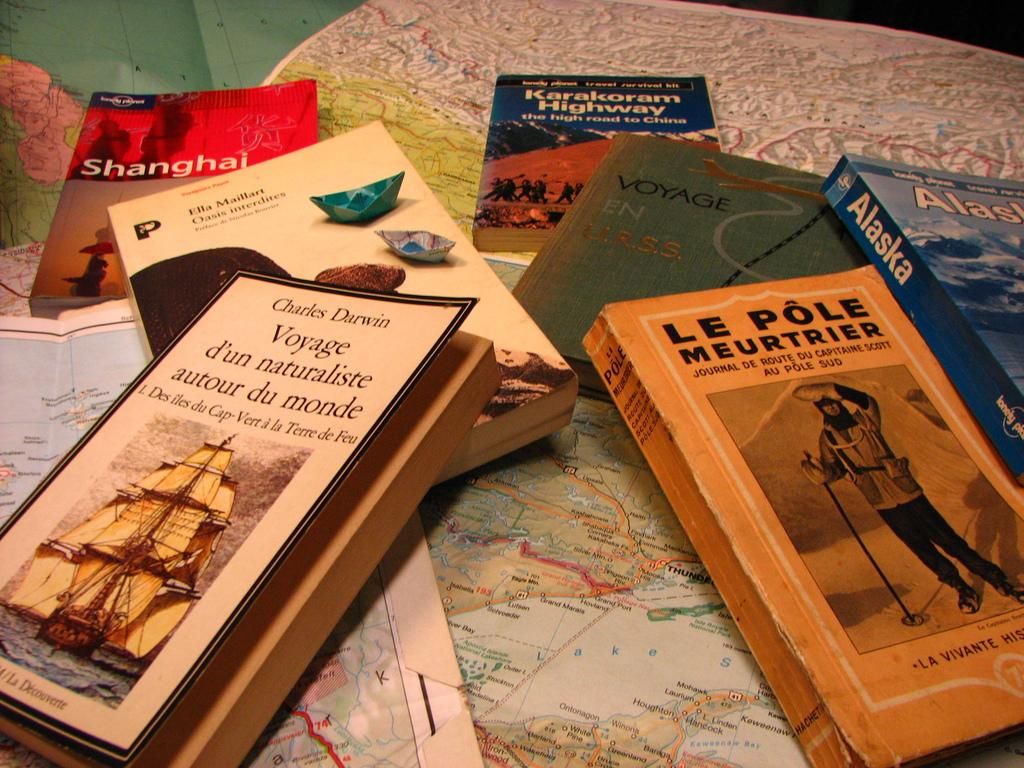<image>
Render a clear and concise summary of the photo. various books with one being le pole meurtrier 